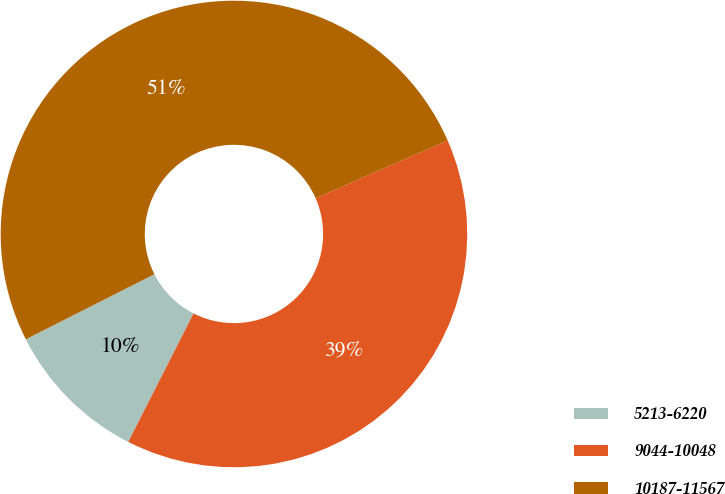<chart> <loc_0><loc_0><loc_500><loc_500><pie_chart><fcel>5213-6220<fcel>9044-10048<fcel>10187-11567<nl><fcel>10.06%<fcel>39.05%<fcel>50.89%<nl></chart> 